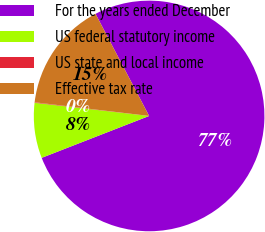Convert chart. <chart><loc_0><loc_0><loc_500><loc_500><pie_chart><fcel>For the years ended December<fcel>US federal statutory income<fcel>US state and local income<fcel>Effective tax rate<nl><fcel>76.77%<fcel>7.74%<fcel>0.07%<fcel>15.41%<nl></chart> 